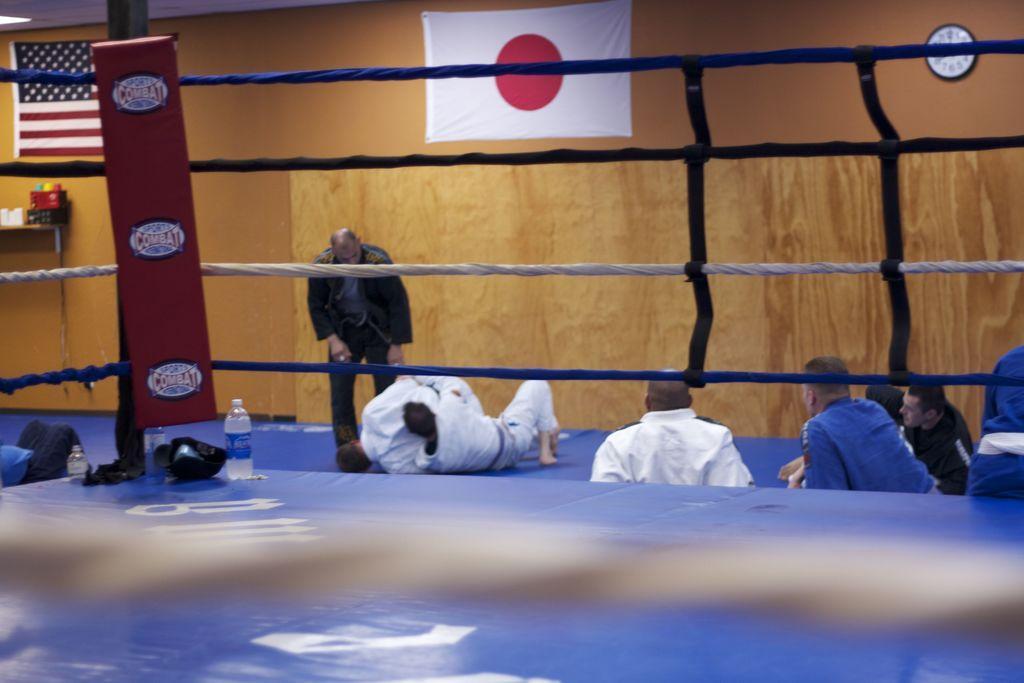How would you summarize this image in a sentence or two? In the center of the image we can see a boxing coat and also we can see bottles, helmet and some objects. In the background of the image we can see the flags, wall clock, some objects, wall, board, a man is standing and some persons are lying on the floor. 